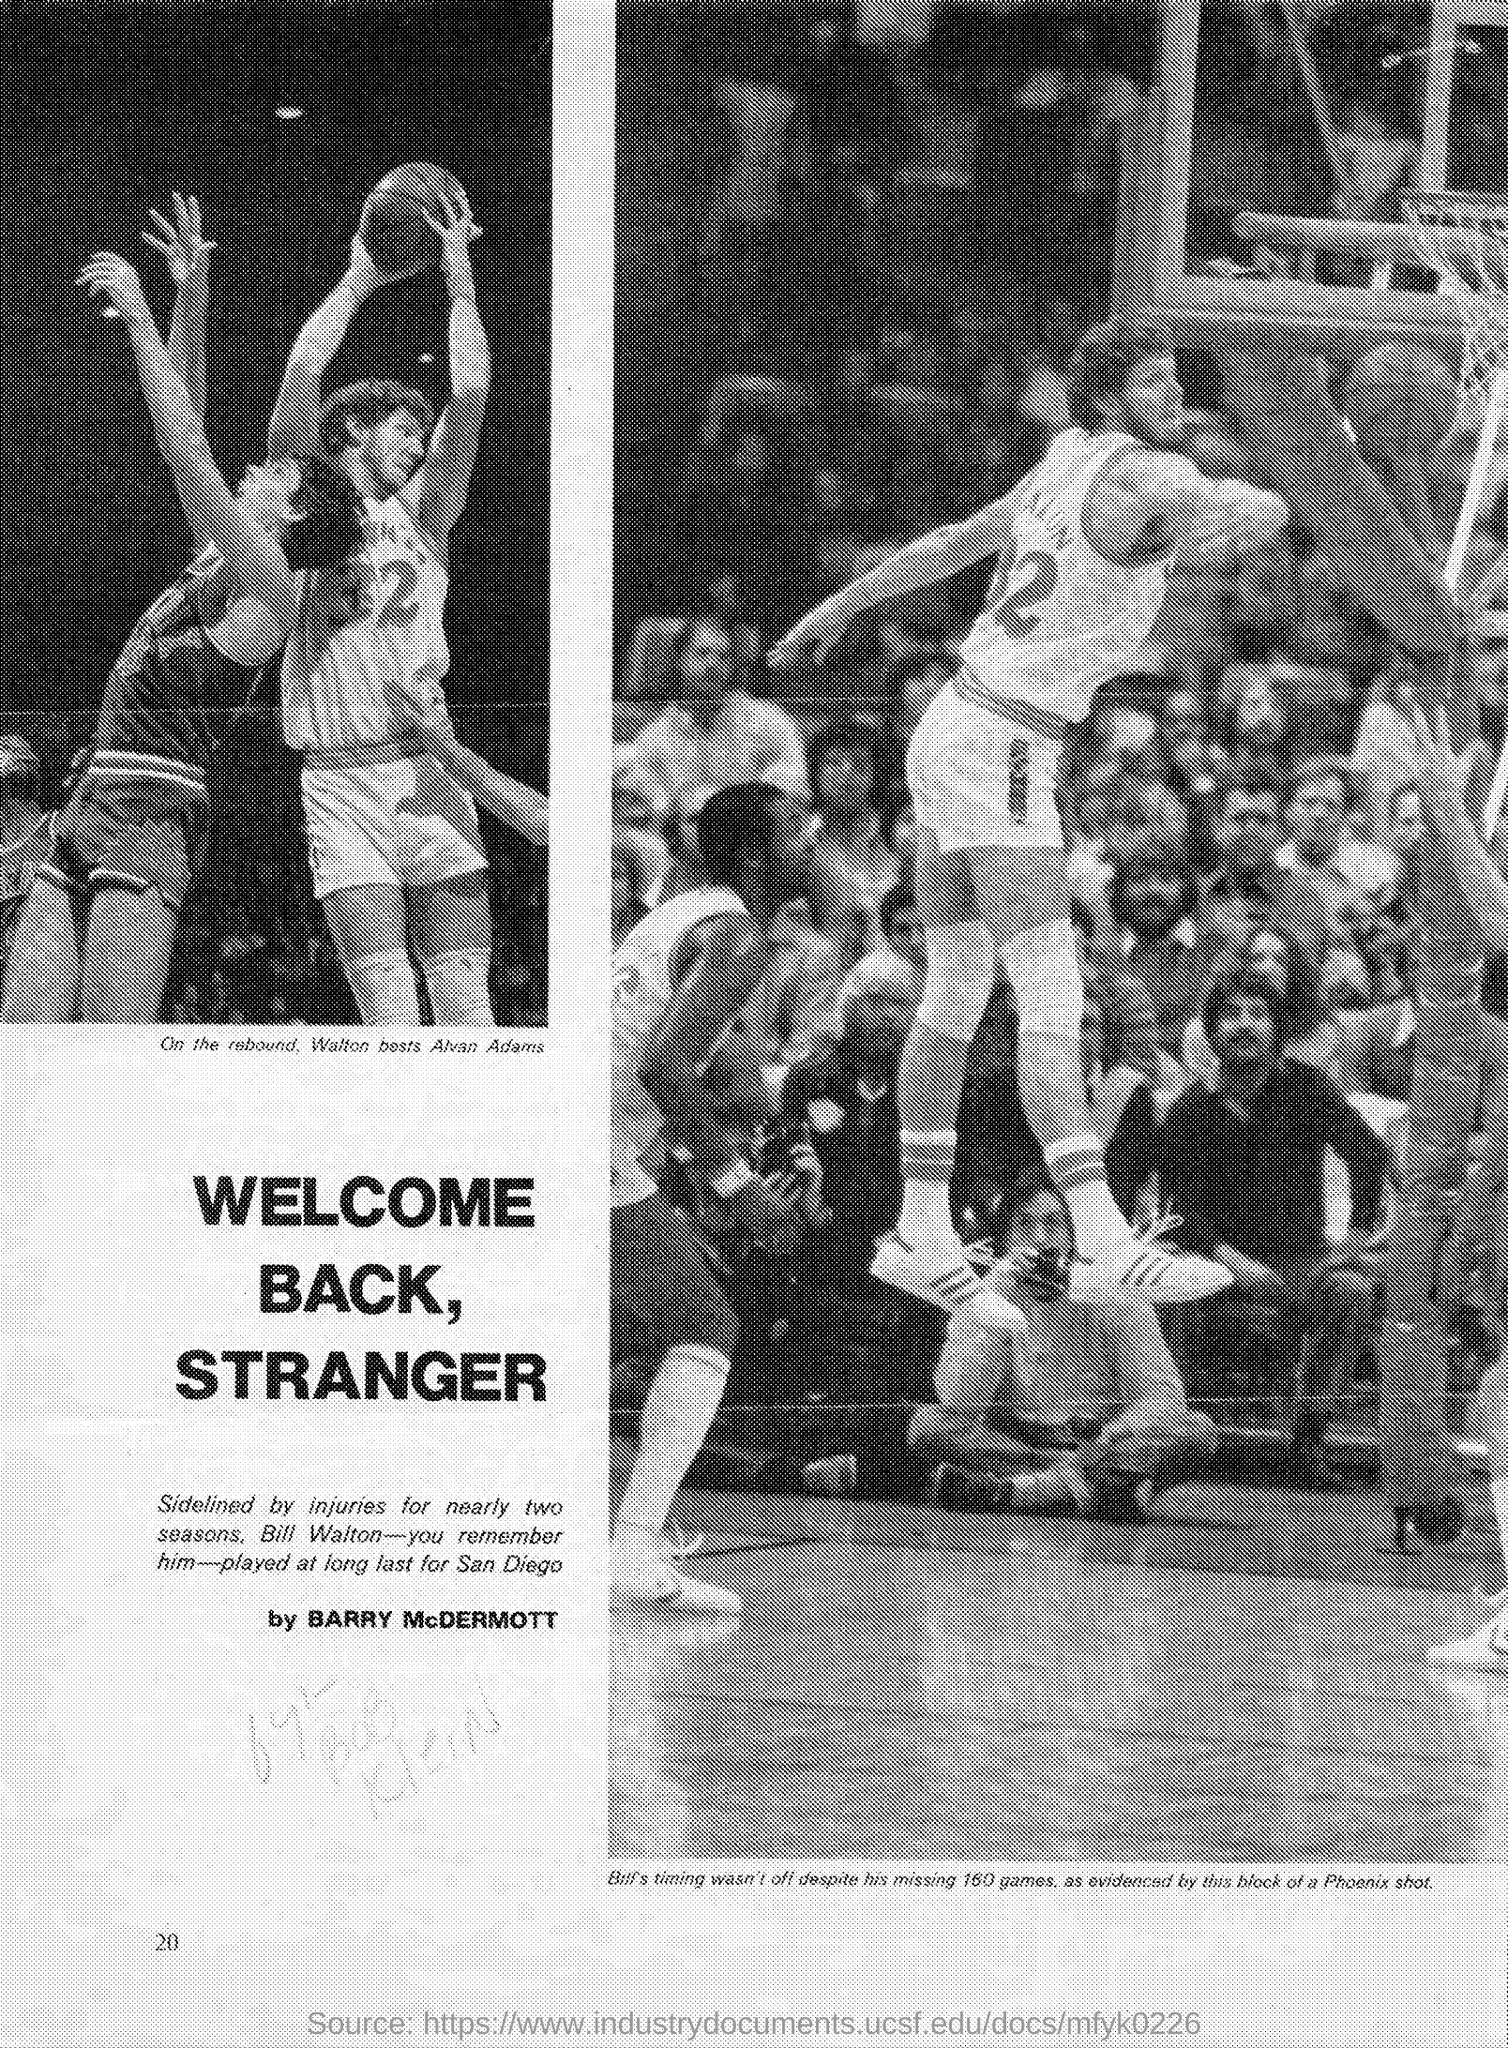Mention a couple of crucial points in this snapshot. Bill Walton was sidelined by injuries, causing him to miss out on playing. Bill was playing for the San Diego team. Barry McDermott wrote this. 